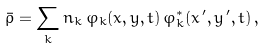<formula> <loc_0><loc_0><loc_500><loc_500>\bar { \rho } = \sum _ { k } n _ { k } \, \varphi _ { k } ( x , y , t ) \, \varphi ^ { * } _ { k } ( x ^ { \, \prime } , y ^ { \, \prime } , t ) \, ,</formula> 